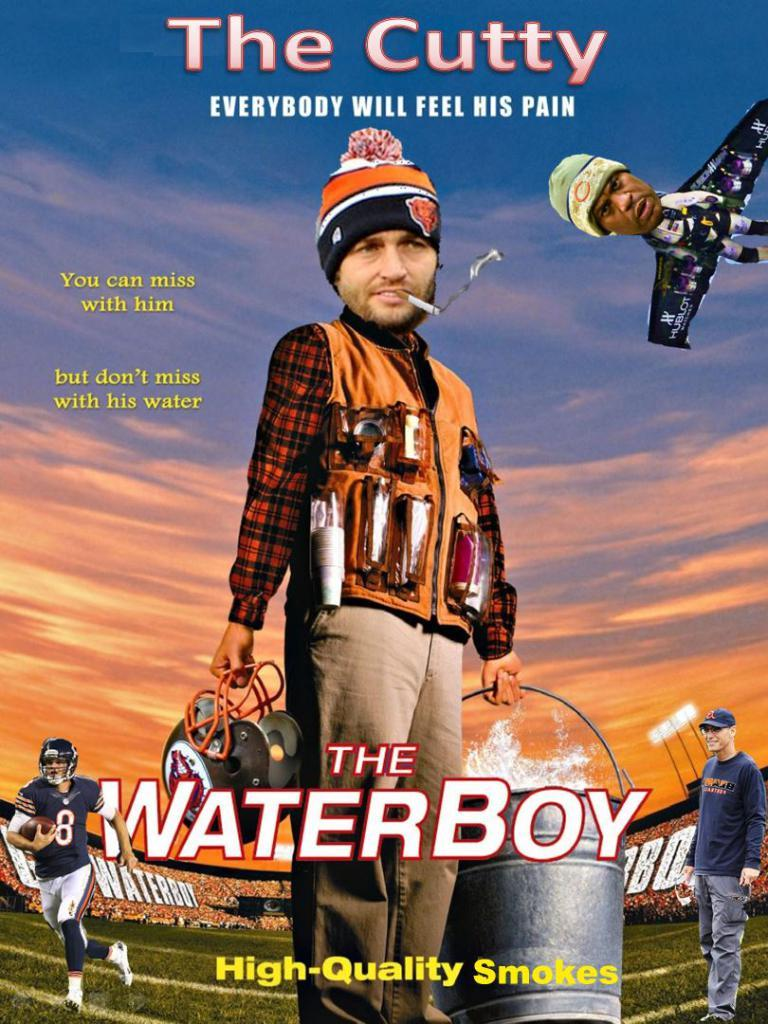What is the main subject of the image? There is an advertisement in the image. How many ants are crawling on the advertisement in the image? There are no ants present in the image; it features an advertisement. What type of riddle can be solved by looking at the advertisement in the image? There is no riddle associated with the advertisement in the image. 